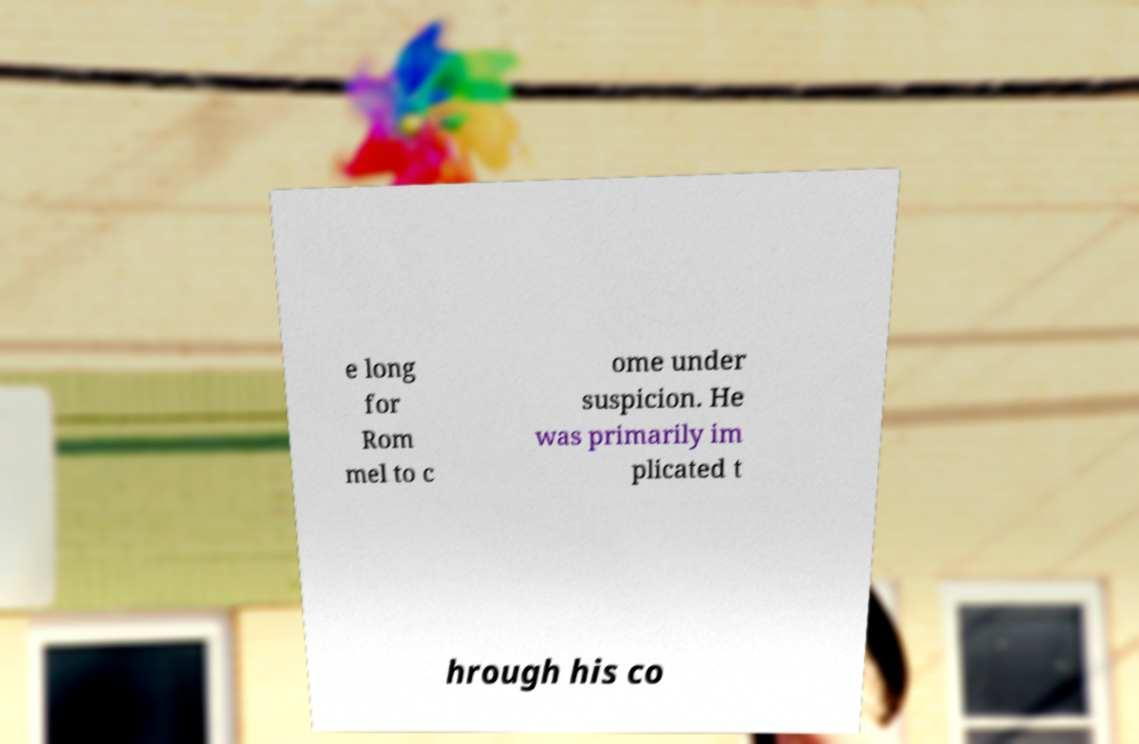I need the written content from this picture converted into text. Can you do that? e long for Rom mel to c ome under suspicion. He was primarily im plicated t hrough his co 